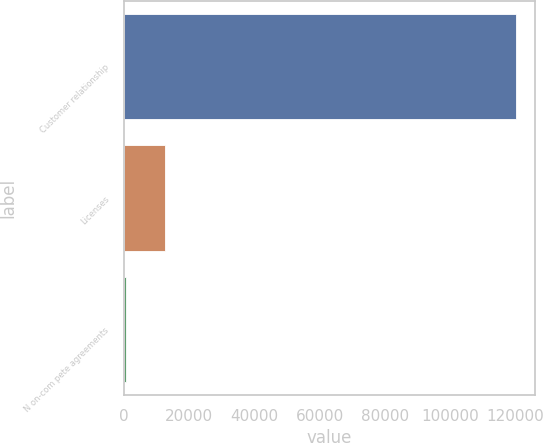<chart> <loc_0><loc_0><loc_500><loc_500><bar_chart><fcel>Customer relationship<fcel>Licenses<fcel>N on-com pete agreements<nl><fcel>120000<fcel>12594<fcel>660<nl></chart> 